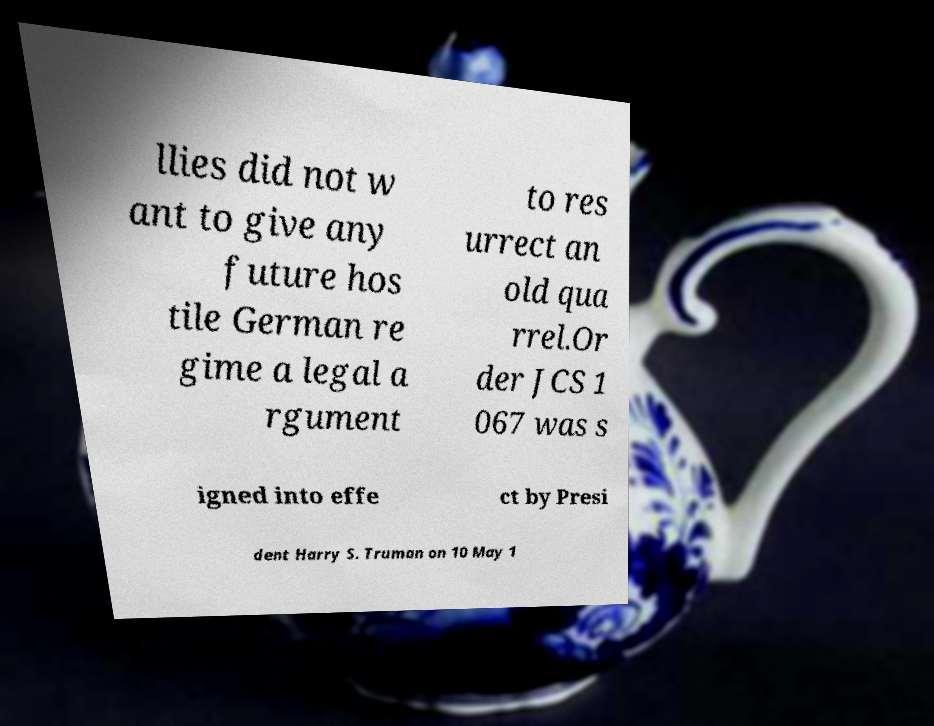For documentation purposes, I need the text within this image transcribed. Could you provide that? llies did not w ant to give any future hos tile German re gime a legal a rgument to res urrect an old qua rrel.Or der JCS 1 067 was s igned into effe ct by Presi dent Harry S. Truman on 10 May 1 